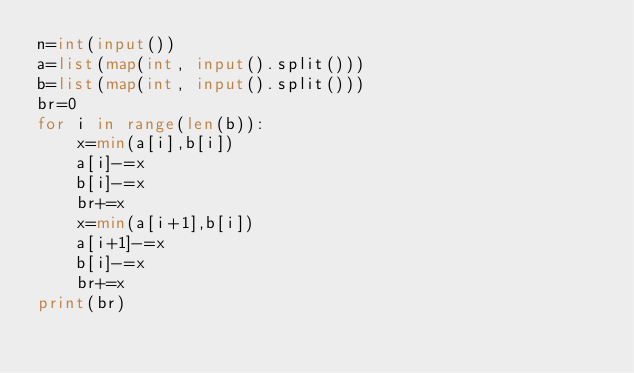<code> <loc_0><loc_0><loc_500><loc_500><_Python_>n=int(input())
a=list(map(int, input().split()))
b=list(map(int, input().split()))
br=0
for i in range(len(b)):
    x=min(a[i],b[i])
    a[i]-=x
    b[i]-=x
    br+=x
    x=min(a[i+1],b[i])
    a[i+1]-=x
    b[i]-=x
    br+=x
print(br)
</code> 